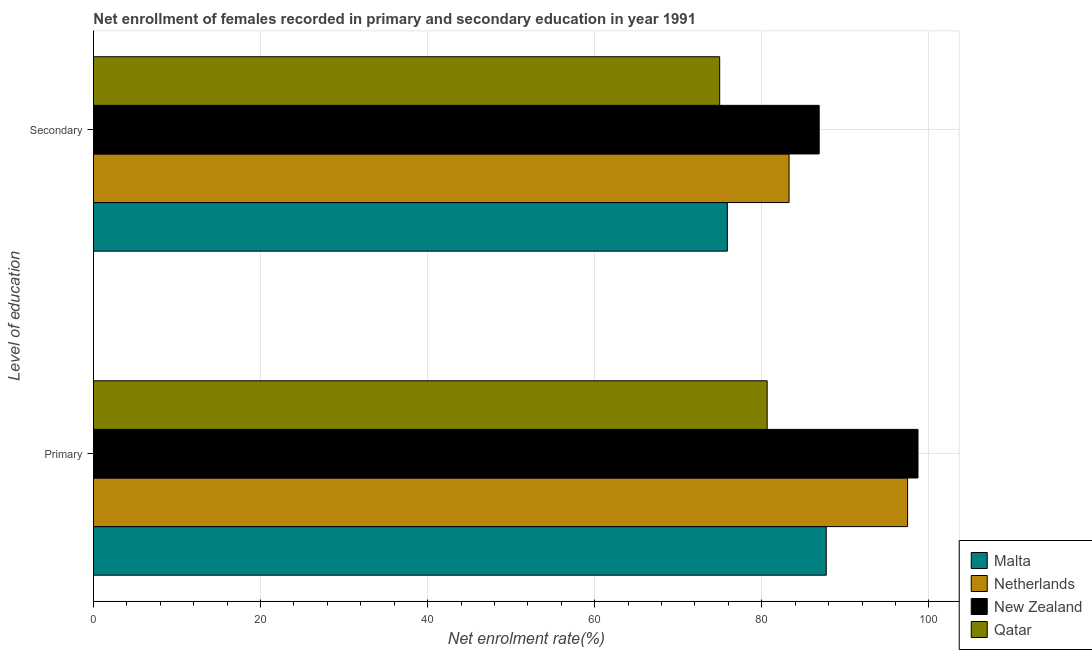How many groups of bars are there?
Keep it short and to the point. 2. Are the number of bars per tick equal to the number of legend labels?
Offer a terse response. Yes. Are the number of bars on each tick of the Y-axis equal?
Your response must be concise. Yes. How many bars are there on the 1st tick from the top?
Provide a short and direct response. 4. How many bars are there on the 2nd tick from the bottom?
Provide a succinct answer. 4. What is the label of the 2nd group of bars from the top?
Your response must be concise. Primary. What is the enrollment rate in secondary education in Malta?
Your response must be concise. 75.87. Across all countries, what is the maximum enrollment rate in primary education?
Provide a short and direct response. 98.69. Across all countries, what is the minimum enrollment rate in primary education?
Provide a short and direct response. 80.64. In which country was the enrollment rate in secondary education maximum?
Keep it short and to the point. New Zealand. In which country was the enrollment rate in primary education minimum?
Provide a short and direct response. Qatar. What is the total enrollment rate in secondary education in the graph?
Give a very brief answer. 320.96. What is the difference between the enrollment rate in primary education in Qatar and that in Netherlands?
Keep it short and to the point. -16.81. What is the difference between the enrollment rate in primary education in Qatar and the enrollment rate in secondary education in Netherlands?
Provide a short and direct response. -2.63. What is the average enrollment rate in secondary education per country?
Keep it short and to the point. 80.24. What is the difference between the enrollment rate in secondary education and enrollment rate in primary education in Qatar?
Your answer should be compact. -5.68. In how many countries, is the enrollment rate in secondary education greater than 36 %?
Offer a very short reply. 4. What is the ratio of the enrollment rate in secondary education in Netherlands to that in Malta?
Offer a very short reply. 1.1. Is the enrollment rate in primary education in Malta less than that in Qatar?
Give a very brief answer. No. What does the 2nd bar from the top in Primary represents?
Offer a terse response. New Zealand. What does the 4th bar from the bottom in Primary represents?
Give a very brief answer. Qatar. How many bars are there?
Ensure brevity in your answer.  8. Does the graph contain any zero values?
Your response must be concise. No. What is the title of the graph?
Provide a short and direct response. Net enrollment of females recorded in primary and secondary education in year 1991. Does "Peru" appear as one of the legend labels in the graph?
Ensure brevity in your answer.  No. What is the label or title of the X-axis?
Provide a succinct answer. Net enrolment rate(%). What is the label or title of the Y-axis?
Your response must be concise. Level of education. What is the Net enrolment rate(%) in Malta in Primary?
Your answer should be very brief. 87.71. What is the Net enrolment rate(%) of Netherlands in Primary?
Make the answer very short. 97.45. What is the Net enrolment rate(%) of New Zealand in Primary?
Your response must be concise. 98.69. What is the Net enrolment rate(%) of Qatar in Primary?
Provide a short and direct response. 80.64. What is the Net enrolment rate(%) of Malta in Secondary?
Keep it short and to the point. 75.87. What is the Net enrolment rate(%) in Netherlands in Secondary?
Your answer should be compact. 83.26. What is the Net enrolment rate(%) in New Zealand in Secondary?
Provide a succinct answer. 86.87. What is the Net enrolment rate(%) of Qatar in Secondary?
Your answer should be compact. 74.96. Across all Level of education, what is the maximum Net enrolment rate(%) of Malta?
Keep it short and to the point. 87.71. Across all Level of education, what is the maximum Net enrolment rate(%) of Netherlands?
Your response must be concise. 97.45. Across all Level of education, what is the maximum Net enrolment rate(%) of New Zealand?
Give a very brief answer. 98.69. Across all Level of education, what is the maximum Net enrolment rate(%) in Qatar?
Provide a short and direct response. 80.64. Across all Level of education, what is the minimum Net enrolment rate(%) of Malta?
Ensure brevity in your answer.  75.87. Across all Level of education, what is the minimum Net enrolment rate(%) of Netherlands?
Offer a terse response. 83.26. Across all Level of education, what is the minimum Net enrolment rate(%) of New Zealand?
Keep it short and to the point. 86.87. Across all Level of education, what is the minimum Net enrolment rate(%) of Qatar?
Give a very brief answer. 74.96. What is the total Net enrolment rate(%) in Malta in the graph?
Ensure brevity in your answer.  163.59. What is the total Net enrolment rate(%) in Netherlands in the graph?
Your answer should be very brief. 180.71. What is the total Net enrolment rate(%) in New Zealand in the graph?
Your answer should be compact. 185.56. What is the total Net enrolment rate(%) of Qatar in the graph?
Provide a succinct answer. 155.6. What is the difference between the Net enrolment rate(%) in Malta in Primary and that in Secondary?
Offer a terse response. 11.84. What is the difference between the Net enrolment rate(%) of Netherlands in Primary and that in Secondary?
Your response must be concise. 14.18. What is the difference between the Net enrolment rate(%) of New Zealand in Primary and that in Secondary?
Make the answer very short. 11.83. What is the difference between the Net enrolment rate(%) of Qatar in Primary and that in Secondary?
Offer a very short reply. 5.68. What is the difference between the Net enrolment rate(%) of Malta in Primary and the Net enrolment rate(%) of Netherlands in Secondary?
Keep it short and to the point. 4.45. What is the difference between the Net enrolment rate(%) of Malta in Primary and the Net enrolment rate(%) of New Zealand in Secondary?
Your answer should be very brief. 0.84. What is the difference between the Net enrolment rate(%) in Malta in Primary and the Net enrolment rate(%) in Qatar in Secondary?
Your answer should be very brief. 12.76. What is the difference between the Net enrolment rate(%) in Netherlands in Primary and the Net enrolment rate(%) in New Zealand in Secondary?
Keep it short and to the point. 10.58. What is the difference between the Net enrolment rate(%) in Netherlands in Primary and the Net enrolment rate(%) in Qatar in Secondary?
Offer a terse response. 22.49. What is the difference between the Net enrolment rate(%) in New Zealand in Primary and the Net enrolment rate(%) in Qatar in Secondary?
Keep it short and to the point. 23.74. What is the average Net enrolment rate(%) in Malta per Level of education?
Provide a succinct answer. 81.79. What is the average Net enrolment rate(%) in Netherlands per Level of education?
Your response must be concise. 90.36. What is the average Net enrolment rate(%) of New Zealand per Level of education?
Provide a succinct answer. 92.78. What is the average Net enrolment rate(%) in Qatar per Level of education?
Offer a terse response. 77.8. What is the difference between the Net enrolment rate(%) in Malta and Net enrolment rate(%) in Netherlands in Primary?
Ensure brevity in your answer.  -9.74. What is the difference between the Net enrolment rate(%) in Malta and Net enrolment rate(%) in New Zealand in Primary?
Offer a terse response. -10.98. What is the difference between the Net enrolment rate(%) of Malta and Net enrolment rate(%) of Qatar in Primary?
Keep it short and to the point. 7.07. What is the difference between the Net enrolment rate(%) in Netherlands and Net enrolment rate(%) in New Zealand in Primary?
Offer a terse response. -1.25. What is the difference between the Net enrolment rate(%) in Netherlands and Net enrolment rate(%) in Qatar in Primary?
Provide a succinct answer. 16.81. What is the difference between the Net enrolment rate(%) of New Zealand and Net enrolment rate(%) of Qatar in Primary?
Give a very brief answer. 18.06. What is the difference between the Net enrolment rate(%) of Malta and Net enrolment rate(%) of Netherlands in Secondary?
Keep it short and to the point. -7.39. What is the difference between the Net enrolment rate(%) of Malta and Net enrolment rate(%) of New Zealand in Secondary?
Provide a succinct answer. -10.99. What is the difference between the Net enrolment rate(%) in Malta and Net enrolment rate(%) in Qatar in Secondary?
Give a very brief answer. 0.92. What is the difference between the Net enrolment rate(%) of Netherlands and Net enrolment rate(%) of New Zealand in Secondary?
Offer a terse response. -3.6. What is the difference between the Net enrolment rate(%) of Netherlands and Net enrolment rate(%) of Qatar in Secondary?
Make the answer very short. 8.31. What is the difference between the Net enrolment rate(%) in New Zealand and Net enrolment rate(%) in Qatar in Secondary?
Offer a terse response. 11.91. What is the ratio of the Net enrolment rate(%) in Malta in Primary to that in Secondary?
Make the answer very short. 1.16. What is the ratio of the Net enrolment rate(%) of Netherlands in Primary to that in Secondary?
Offer a terse response. 1.17. What is the ratio of the Net enrolment rate(%) of New Zealand in Primary to that in Secondary?
Offer a terse response. 1.14. What is the ratio of the Net enrolment rate(%) of Qatar in Primary to that in Secondary?
Your response must be concise. 1.08. What is the difference between the highest and the second highest Net enrolment rate(%) in Malta?
Offer a terse response. 11.84. What is the difference between the highest and the second highest Net enrolment rate(%) in Netherlands?
Provide a short and direct response. 14.18. What is the difference between the highest and the second highest Net enrolment rate(%) of New Zealand?
Offer a very short reply. 11.83. What is the difference between the highest and the second highest Net enrolment rate(%) of Qatar?
Provide a short and direct response. 5.68. What is the difference between the highest and the lowest Net enrolment rate(%) in Malta?
Provide a short and direct response. 11.84. What is the difference between the highest and the lowest Net enrolment rate(%) of Netherlands?
Ensure brevity in your answer.  14.18. What is the difference between the highest and the lowest Net enrolment rate(%) in New Zealand?
Ensure brevity in your answer.  11.83. What is the difference between the highest and the lowest Net enrolment rate(%) in Qatar?
Give a very brief answer. 5.68. 